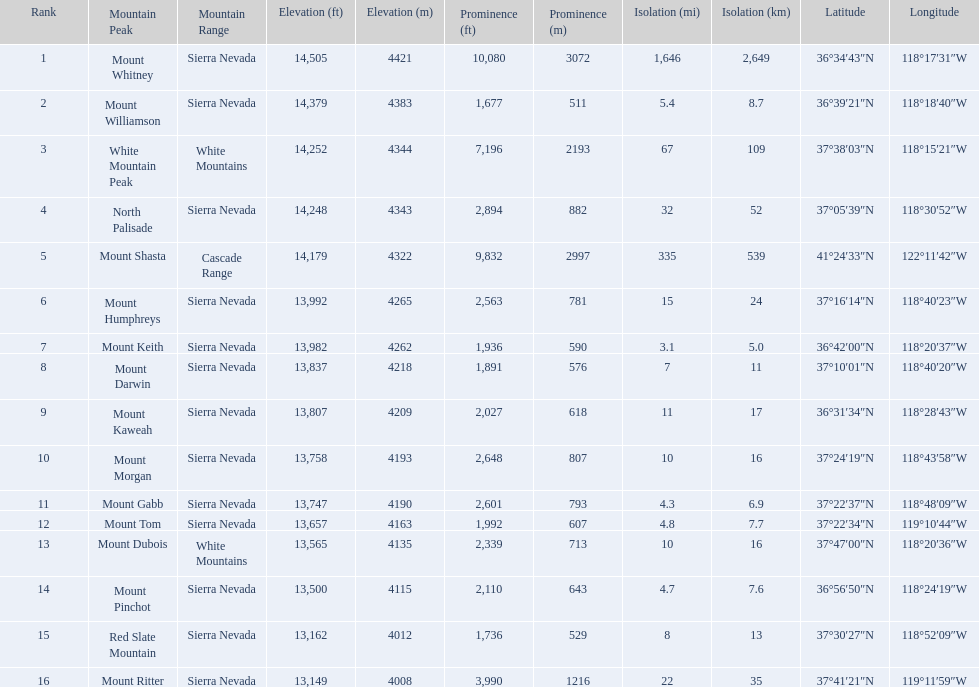What are all of the peaks? Mount Whitney, Mount Williamson, White Mountain Peak, North Palisade, Mount Shasta, Mount Humphreys, Mount Keith, Mount Darwin, Mount Kaweah, Mount Morgan, Mount Gabb, Mount Tom, Mount Dubois, Mount Pinchot, Red Slate Mountain, Mount Ritter. Where are they located? Sierra Nevada, Sierra Nevada, White Mountains, Sierra Nevada, Cascade Range, Sierra Nevada, Sierra Nevada, Sierra Nevada, Sierra Nevada, Sierra Nevada, Sierra Nevada, Sierra Nevada, White Mountains, Sierra Nevada, Sierra Nevada, Sierra Nevada. How tall are they? 14,505 ft\n4421 m, 14,379 ft\n4383 m, 14,252 ft\n4344 m, 14,248 ft\n4343 m, 14,179 ft\n4322 m, 13,992 ft\n4265 m, 13,982 ft\n4262 m, 13,837 ft\n4218 m, 13,807 ft\n4209 m, 13,758 ft\n4193 m, 13,747 ft\n4190 m, 13,657 ft\n4163 m, 13,565 ft\n4135 m, 13,500 ft\n4115 m, 13,162 ft\n4012 m, 13,149 ft\n4008 m. What about just the peaks in the sierra nevadas? 14,505 ft\n4421 m, 14,379 ft\n4383 m, 14,248 ft\n4343 m, 13,992 ft\n4265 m, 13,982 ft\n4262 m, 13,837 ft\n4218 m, 13,807 ft\n4209 m, 13,758 ft\n4193 m, 13,747 ft\n4190 m, 13,657 ft\n4163 m, 13,500 ft\n4115 m, 13,162 ft\n4012 m, 13,149 ft\n4008 m. And of those, which is the tallest? Mount Whitney. 